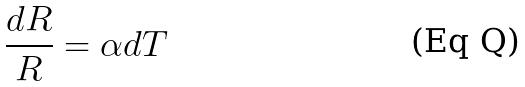<formula> <loc_0><loc_0><loc_500><loc_500>\frac { d R } { R } = \alpha d T</formula> 